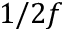<formula> <loc_0><loc_0><loc_500><loc_500>1 / 2 f</formula> 